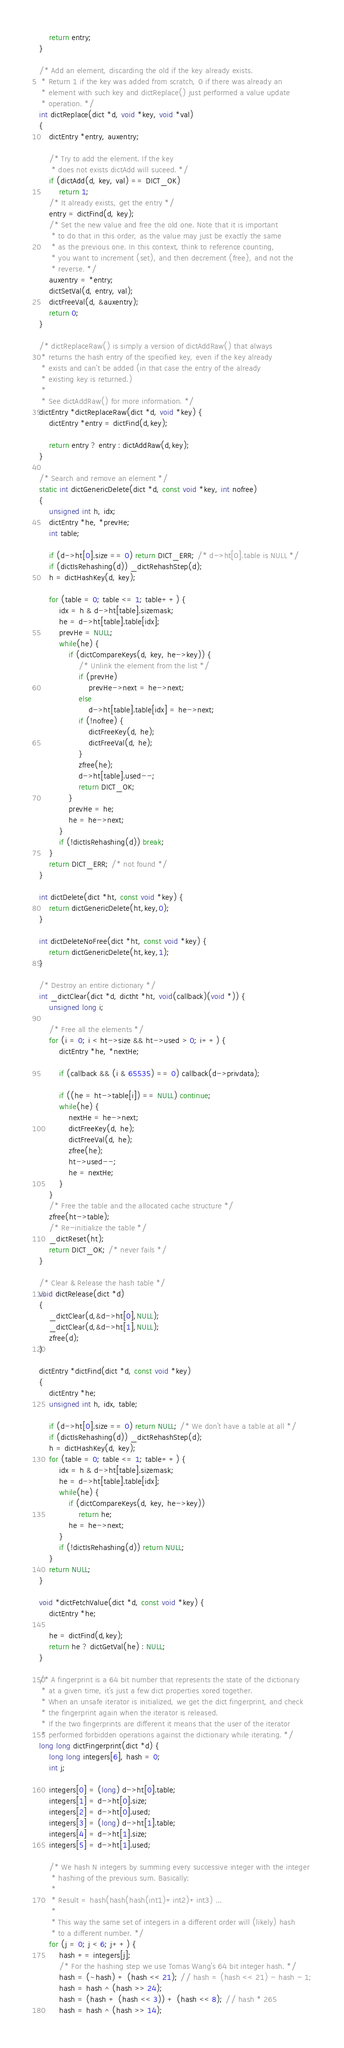Convert code to text. <code><loc_0><loc_0><loc_500><loc_500><_C_>    return entry;
}

/* Add an element, discarding the old if the key already exists.
 * Return 1 if the key was added from scratch, 0 if there was already an
 * element with such key and dictReplace() just performed a value update
 * operation. */
int dictReplace(dict *d, void *key, void *val)
{
    dictEntry *entry, auxentry;

    /* Try to add the element. If the key
     * does not exists dictAdd will suceed. */
    if (dictAdd(d, key, val) == DICT_OK)
        return 1;
    /* It already exists, get the entry */
    entry = dictFind(d, key);
    /* Set the new value and free the old one. Note that it is important
     * to do that in this order, as the value may just be exactly the same
     * as the previous one. In this context, think to reference counting,
     * you want to increment (set), and then decrement (free), and not the
     * reverse. */
    auxentry = *entry;
    dictSetVal(d, entry, val);
    dictFreeVal(d, &auxentry);
    return 0;
}

/* dictReplaceRaw() is simply a version of dictAddRaw() that always
 * returns the hash entry of the specified key, even if the key already
 * exists and can't be added (in that case the entry of the already
 * existing key is returned.)
 *
 * See dictAddRaw() for more information. */
dictEntry *dictReplaceRaw(dict *d, void *key) {
    dictEntry *entry = dictFind(d,key);

    return entry ? entry : dictAddRaw(d,key);
}

/* Search and remove an element */
static int dictGenericDelete(dict *d, const void *key, int nofree)
{
    unsigned int h, idx;
    dictEntry *he, *prevHe;
    int table;

    if (d->ht[0].size == 0) return DICT_ERR; /* d->ht[0].table is NULL */
    if (dictIsRehashing(d)) _dictRehashStep(d);
    h = dictHashKey(d, key);

    for (table = 0; table <= 1; table++) {
        idx = h & d->ht[table].sizemask;
        he = d->ht[table].table[idx];
        prevHe = NULL;
        while(he) {
            if (dictCompareKeys(d, key, he->key)) {
                /* Unlink the element from the list */
                if (prevHe)
                    prevHe->next = he->next;
                else
                    d->ht[table].table[idx] = he->next;
                if (!nofree) {
                    dictFreeKey(d, he);
                    dictFreeVal(d, he);
                }
                zfree(he);
                d->ht[table].used--;
                return DICT_OK;
            }
            prevHe = he;
            he = he->next;
        }
        if (!dictIsRehashing(d)) break;
    }
    return DICT_ERR; /* not found */
}

int dictDelete(dict *ht, const void *key) {
    return dictGenericDelete(ht,key,0);
}

int dictDeleteNoFree(dict *ht, const void *key) {
    return dictGenericDelete(ht,key,1);
}

/* Destroy an entire dictionary */
int _dictClear(dict *d, dictht *ht, void(callback)(void *)) {
    unsigned long i;

    /* Free all the elements */
    for (i = 0; i < ht->size && ht->used > 0; i++) {
        dictEntry *he, *nextHe;

        if (callback && (i & 65535) == 0) callback(d->privdata);

        if ((he = ht->table[i]) == NULL) continue;
        while(he) {
            nextHe = he->next;
            dictFreeKey(d, he);
            dictFreeVal(d, he);
            zfree(he);
            ht->used--;
            he = nextHe;
        }
    }
    /* Free the table and the allocated cache structure */
    zfree(ht->table);
    /* Re-initialize the table */
    _dictReset(ht);
    return DICT_OK; /* never fails */
}

/* Clear & Release the hash table */
void dictRelease(dict *d)
{
    _dictClear(d,&d->ht[0],NULL);
    _dictClear(d,&d->ht[1],NULL);
    zfree(d);
}

dictEntry *dictFind(dict *d, const void *key)
{
    dictEntry *he;
    unsigned int h, idx, table;

    if (d->ht[0].size == 0) return NULL; /* We don't have a table at all */
    if (dictIsRehashing(d)) _dictRehashStep(d);
    h = dictHashKey(d, key);
    for (table = 0; table <= 1; table++) {
        idx = h & d->ht[table].sizemask;
        he = d->ht[table].table[idx];
        while(he) {
            if (dictCompareKeys(d, key, he->key))
                return he;
            he = he->next;
        }
        if (!dictIsRehashing(d)) return NULL;
    }
    return NULL;
}

void *dictFetchValue(dict *d, const void *key) {
    dictEntry *he;

    he = dictFind(d,key);
    return he ? dictGetVal(he) : NULL;
}

/* A fingerprint is a 64 bit number that represents the state of the dictionary
 * at a given time, it's just a few dict properties xored together.
 * When an unsafe iterator is initialized, we get the dict fingerprint, and check
 * the fingerprint again when the iterator is released.
 * If the two fingerprints are different it means that the user of the iterator
 * performed forbidden operations against the dictionary while iterating. */
long long dictFingerprint(dict *d) {
    long long integers[6], hash = 0;
    int j;

    integers[0] = (long) d->ht[0].table;
    integers[1] = d->ht[0].size;
    integers[2] = d->ht[0].used;
    integers[3] = (long) d->ht[1].table;
    integers[4] = d->ht[1].size;
    integers[5] = d->ht[1].used;

    /* We hash N integers by summing every successive integer with the integer
     * hashing of the previous sum. Basically:
     *
     * Result = hash(hash(hash(int1)+int2)+int3) ...
     *
     * This way the same set of integers in a different order will (likely) hash
     * to a different number. */
    for (j = 0; j < 6; j++) {
        hash += integers[j];
        /* For the hashing step we use Tomas Wang's 64 bit integer hash. */
        hash = (~hash) + (hash << 21); // hash = (hash << 21) - hash - 1;
        hash = hash ^ (hash >> 24);
        hash = (hash + (hash << 3)) + (hash << 8); // hash * 265
        hash = hash ^ (hash >> 14);</code> 